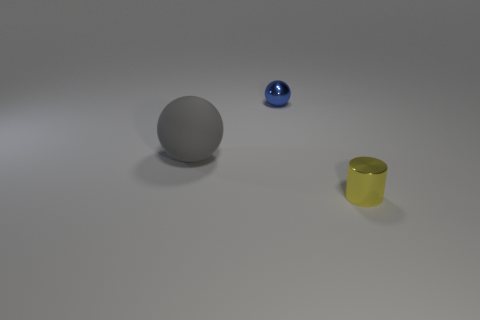Do the yellow metallic cylinder and the thing to the left of the tiny blue metallic sphere have the same size?
Provide a succinct answer. No. There is a metallic object in front of the large gray rubber sphere; what color is it?
Offer a terse response. Yellow. What is the shape of the metal object in front of the small ball?
Make the answer very short. Cylinder. What number of cyan things are either big rubber things or cylinders?
Ensure brevity in your answer.  0. Are the yellow cylinder and the tiny blue ball made of the same material?
Provide a short and direct response. Yes. There is a yellow metallic object; how many tiny blue metallic balls are in front of it?
Offer a terse response. 0. There is a thing that is in front of the small blue object and on the left side of the tiny cylinder; what is it made of?
Keep it short and to the point. Rubber. What number of balls are either large purple metal objects or blue shiny things?
Ensure brevity in your answer.  1. There is another blue thing that is the same shape as the large object; what is it made of?
Offer a very short reply. Metal. The thing that is the same material as the blue sphere is what size?
Keep it short and to the point. Small. 